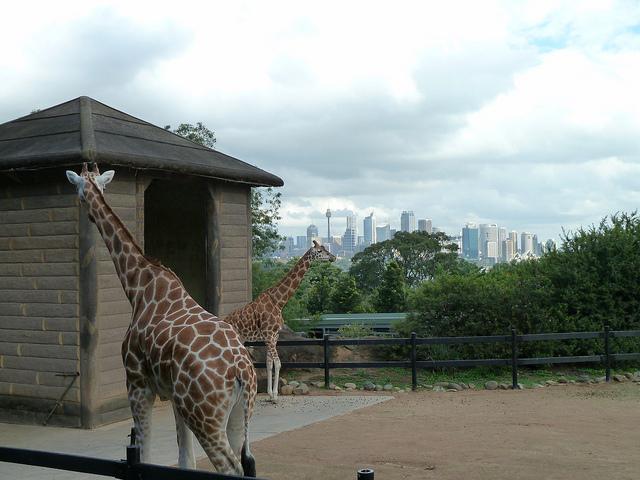What is the view in the background?
Write a very short answer. City. Where is the giraffe that is standing?
Short answer required. Zoo. Is this a zoo?
Give a very brief answer. Yes. How many giraffes are there?
Be succinct. 2. Are these toy giraffes?
Answer briefly. No. How many giraffes are facing the camera?
Keep it brief. 0. Are both of these animals eating?
Give a very brief answer. No. What is the giraffe doing?
Quick response, please. Walking. Is the day clear?
Quick response, please. No. 